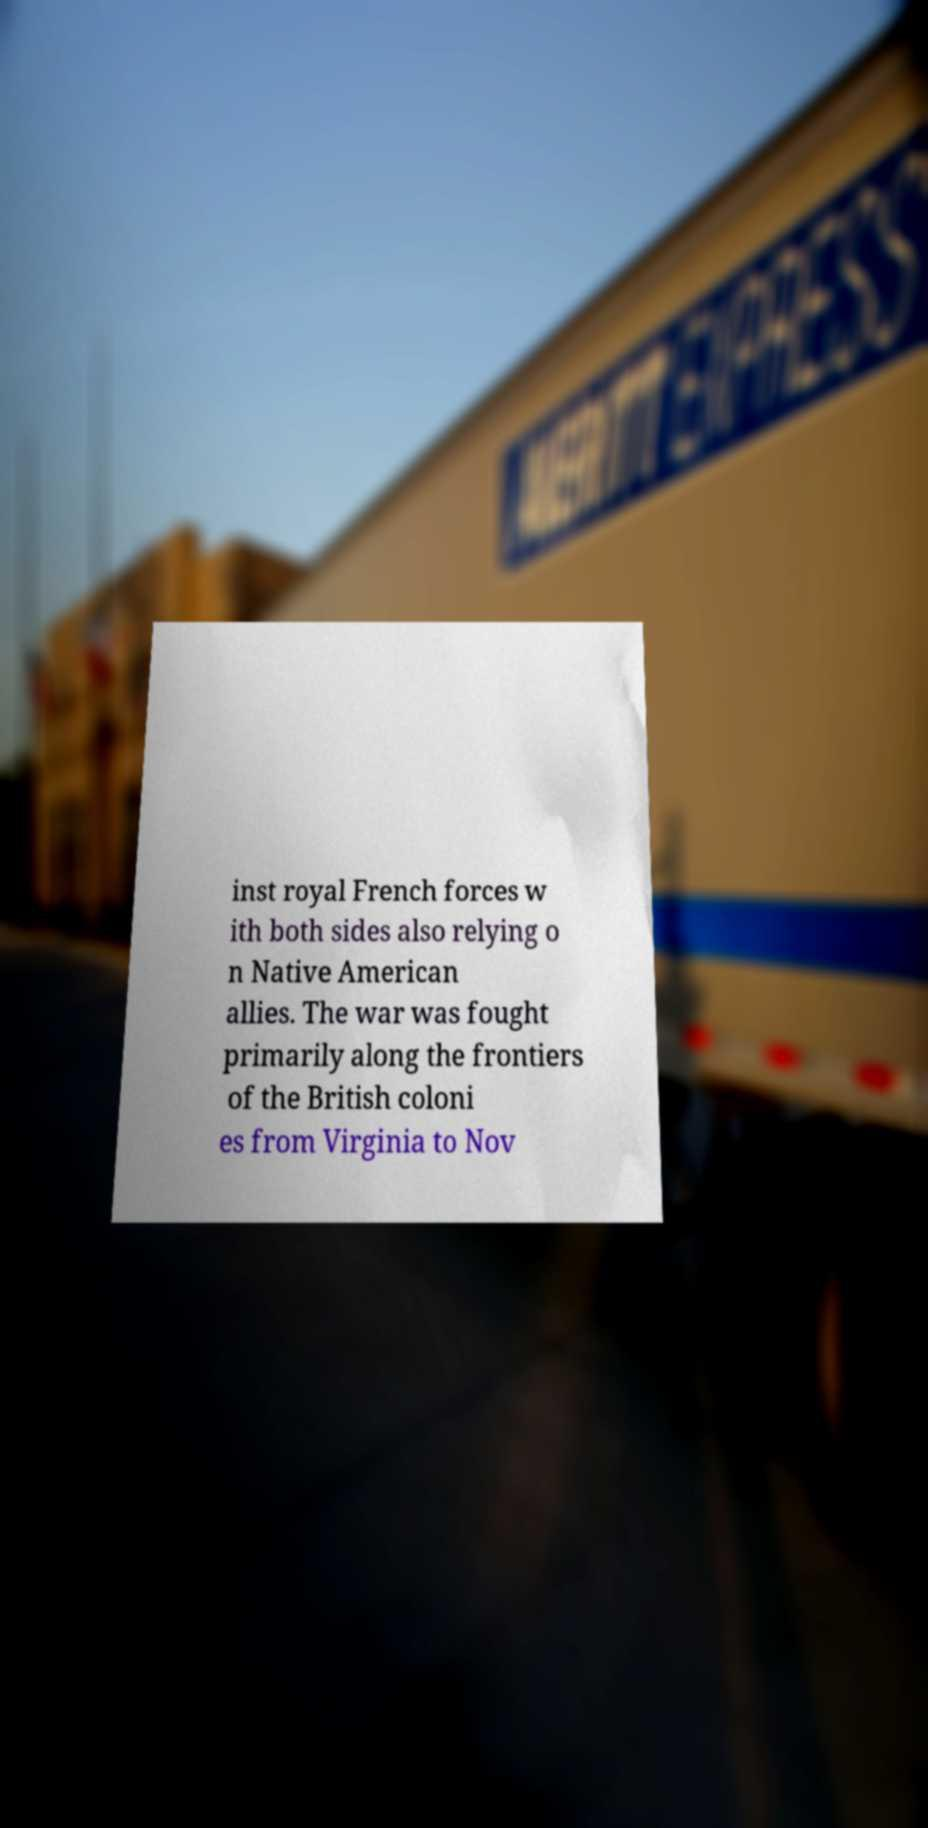I need the written content from this picture converted into text. Can you do that? inst royal French forces w ith both sides also relying o n Native American allies. The war was fought primarily along the frontiers of the British coloni es from Virginia to Nov 